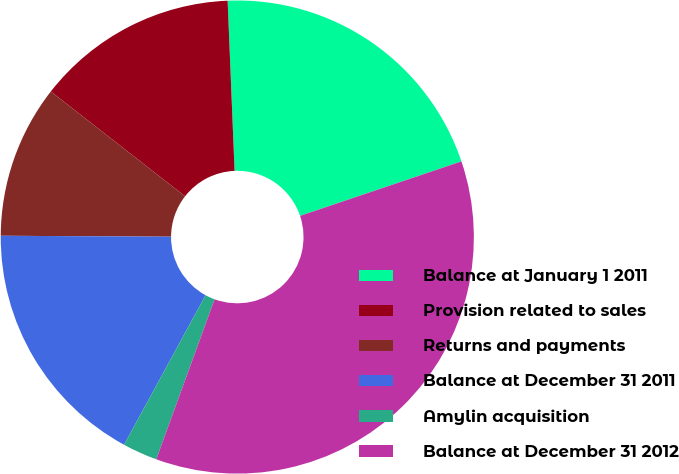Convert chart to OTSL. <chart><loc_0><loc_0><loc_500><loc_500><pie_chart><fcel>Balance at January 1 2011<fcel>Provision related to sales<fcel>Returns and payments<fcel>Balance at December 31 2011<fcel>Amylin acquisition<fcel>Balance at December 31 2012<nl><fcel>20.47%<fcel>13.8%<fcel>10.46%<fcel>17.14%<fcel>2.38%<fcel>35.74%<nl></chart> 